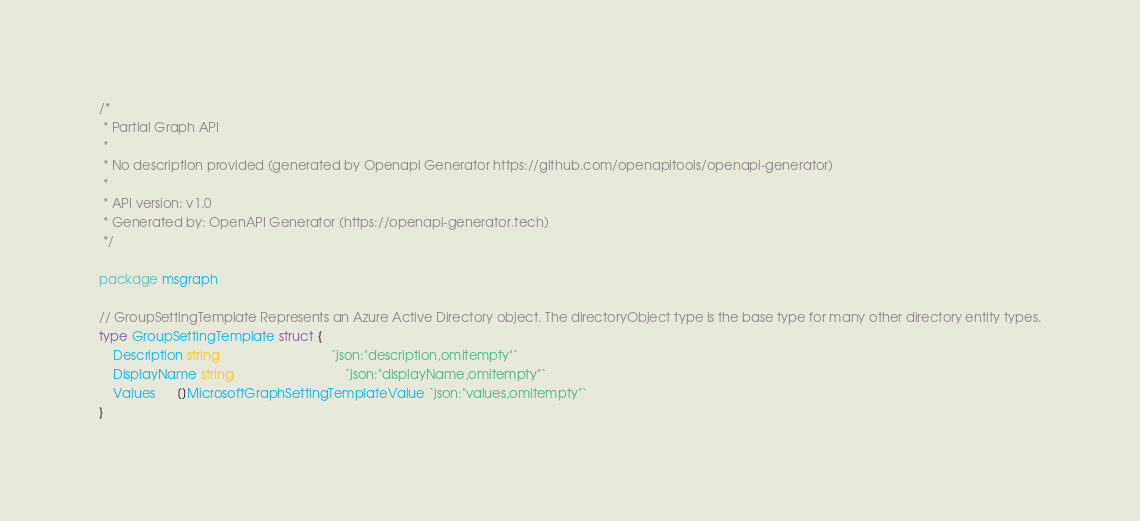Convert code to text. <code><loc_0><loc_0><loc_500><loc_500><_Go_>/*
 * Partial Graph API
 *
 * No description provided (generated by Openapi Generator https://github.com/openapitools/openapi-generator)
 *
 * API version: v1.0
 * Generated by: OpenAPI Generator (https://openapi-generator.tech)
 */

package msgraph

// GroupSettingTemplate Represents an Azure Active Directory object. The directoryObject type is the base type for many other directory entity types.
type GroupSettingTemplate struct {
	Description string                               `json:"description,omitempty"`
	DisplayName string                               `json:"displayName,omitempty"`
	Values      []MicrosoftGraphSettingTemplateValue `json:"values,omitempty"`
}
</code> 